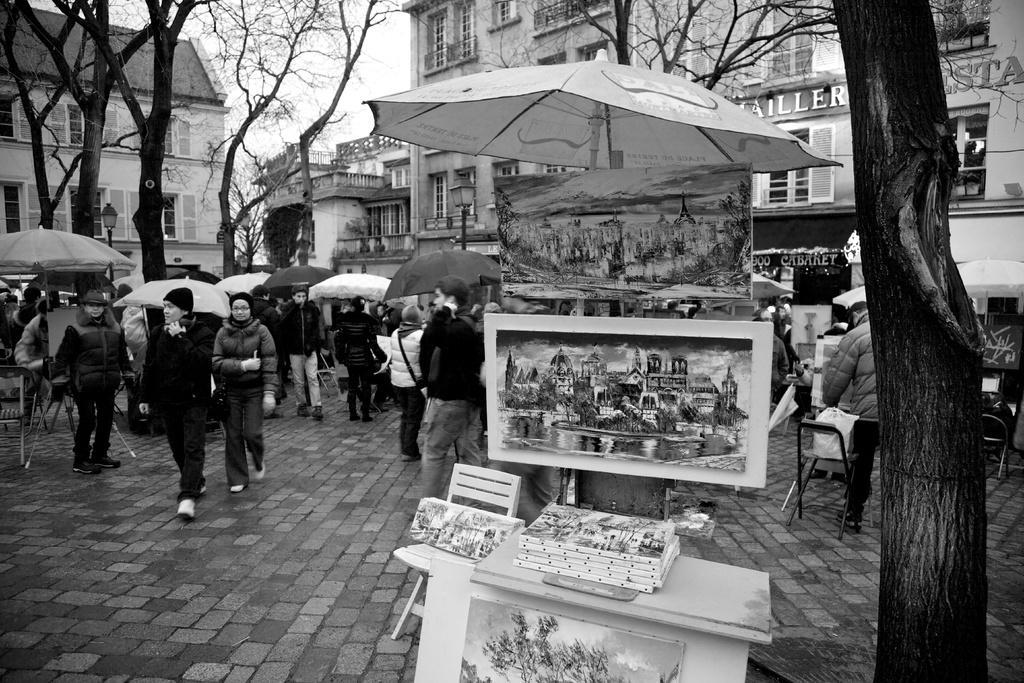How would you summarize this image in a sentence or two? In this picture I can see the table and a stand in front, on which there are paintings and I can see an umbrella and a chair near to the table. In the background I can see number of people on the path and I see that few of them are holding umbrellas and I can see the trees, building and the sky. On the right building I can see something is written. 